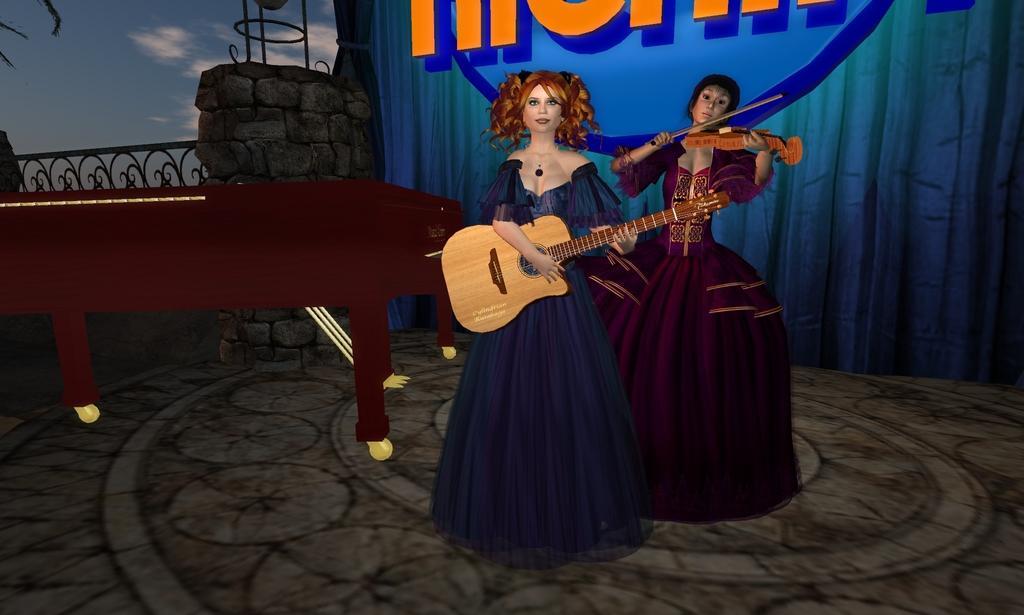Please provide a concise description of this image. In this image I can see the digital art of two women standing and holding musical instruments in their hands. I can see a piano which is maroon in color and in the background I can see the blue colored curtain and the sky. 